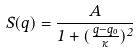<formula> <loc_0><loc_0><loc_500><loc_500>S ( q ) = \frac { A } { 1 + ( \frac { q - q _ { o } } { \kappa } ) ^ { 2 } }</formula> 